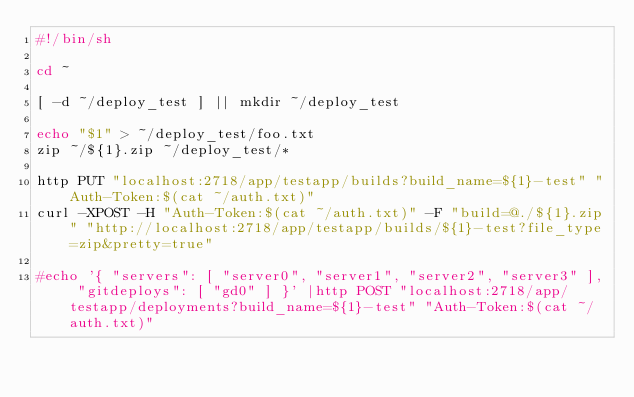<code> <loc_0><loc_0><loc_500><loc_500><_Bash_>#!/bin/sh

cd ~

[ -d ~/deploy_test ] || mkdir ~/deploy_test

echo "$1" > ~/deploy_test/foo.txt
zip ~/${1}.zip ~/deploy_test/*

http PUT "localhost:2718/app/testapp/builds?build_name=${1}-test" "Auth-Token:$(cat ~/auth.txt)"
curl -XPOST -H "Auth-Token:$(cat ~/auth.txt)" -F "build=@./${1}.zip" "http://localhost:2718/app/testapp/builds/${1}-test?file_type=zip&pretty=true"

#echo '{ "servers": [ "server0", "server1", "server2", "server3" ], "gitdeploys": [ "gd0" ] }' |http POST "localhost:2718/app/testapp/deployments?build_name=${1}-test" "Auth-Token:$(cat ~/auth.txt)"



</code> 